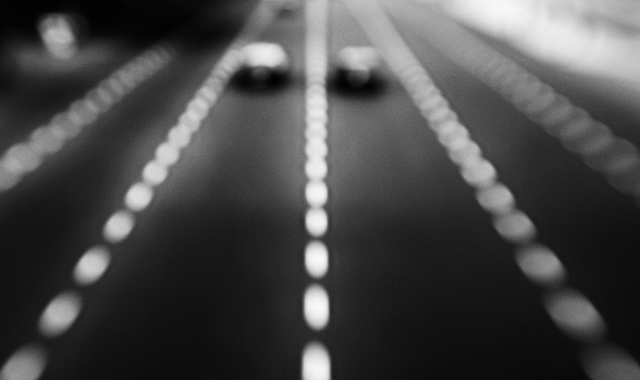Are the texture details of the car lost? Given the blurred nature of the image, it is difficult to discern fine details on any subject, including the car. A crisp texture would require a clearer, focused image. In this case, the artistic intention seems to have been capturing motion or a sensation of speed, rather than the detail of any particular object. 